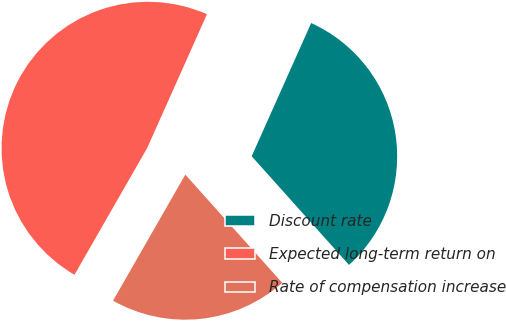Convert chart. <chart><loc_0><loc_0><loc_500><loc_500><pie_chart><fcel>Discount rate<fcel>Expected long-term return on<fcel>Rate of compensation increase<nl><fcel>31.69%<fcel>48.4%<fcel>19.91%<nl></chart> 